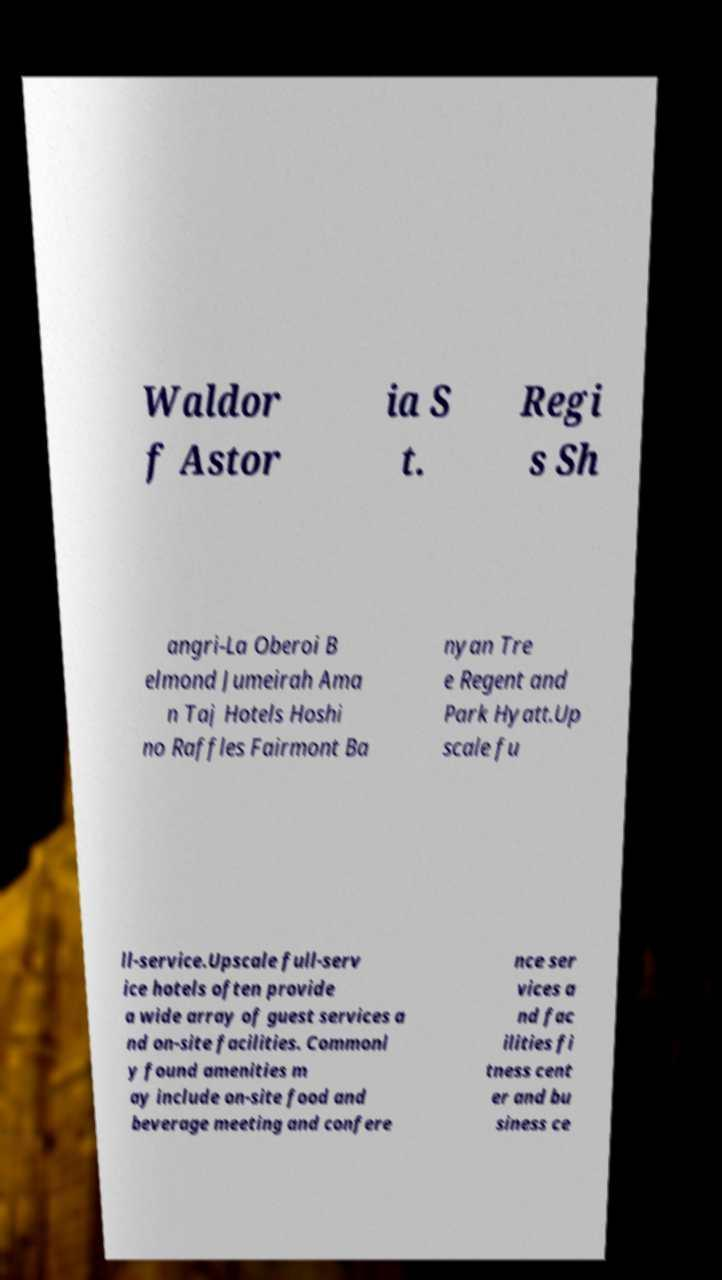There's text embedded in this image that I need extracted. Can you transcribe it verbatim? Waldor f Astor ia S t. Regi s Sh angri-La Oberoi B elmond Jumeirah Ama n Taj Hotels Hoshi no Raffles Fairmont Ba nyan Tre e Regent and Park Hyatt.Up scale fu ll-service.Upscale full-serv ice hotels often provide a wide array of guest services a nd on-site facilities. Commonl y found amenities m ay include on-site food and beverage meeting and confere nce ser vices a nd fac ilities fi tness cent er and bu siness ce 